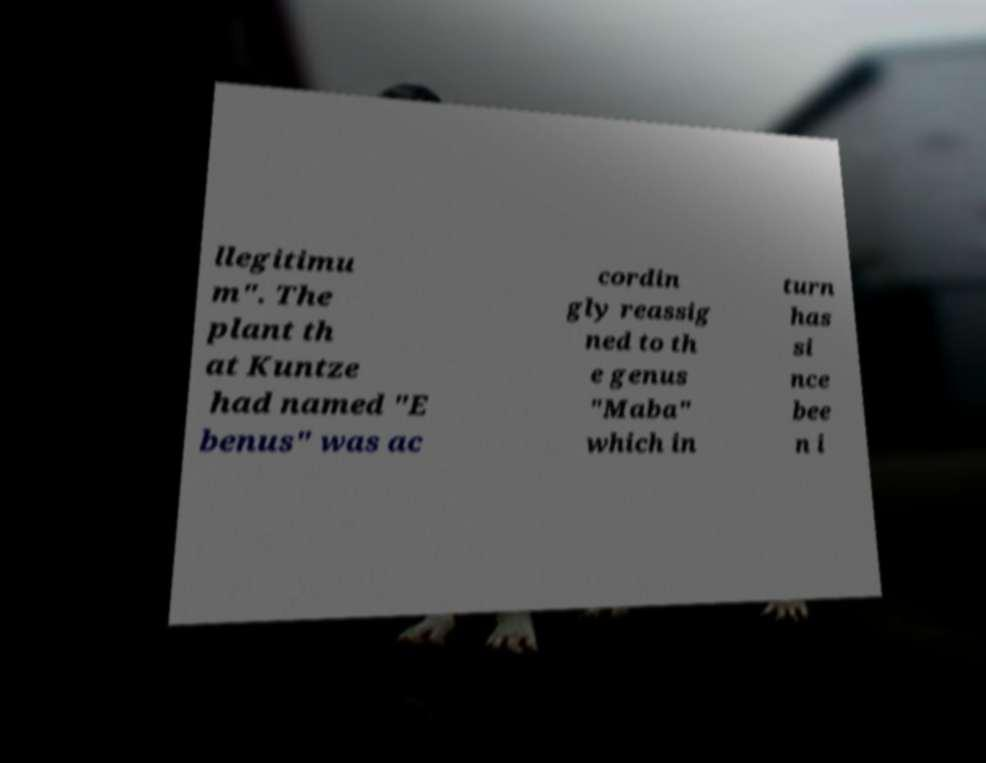For documentation purposes, I need the text within this image transcribed. Could you provide that? llegitimu m". The plant th at Kuntze had named "E benus" was ac cordin gly reassig ned to th e genus "Maba" which in turn has si nce bee n i 